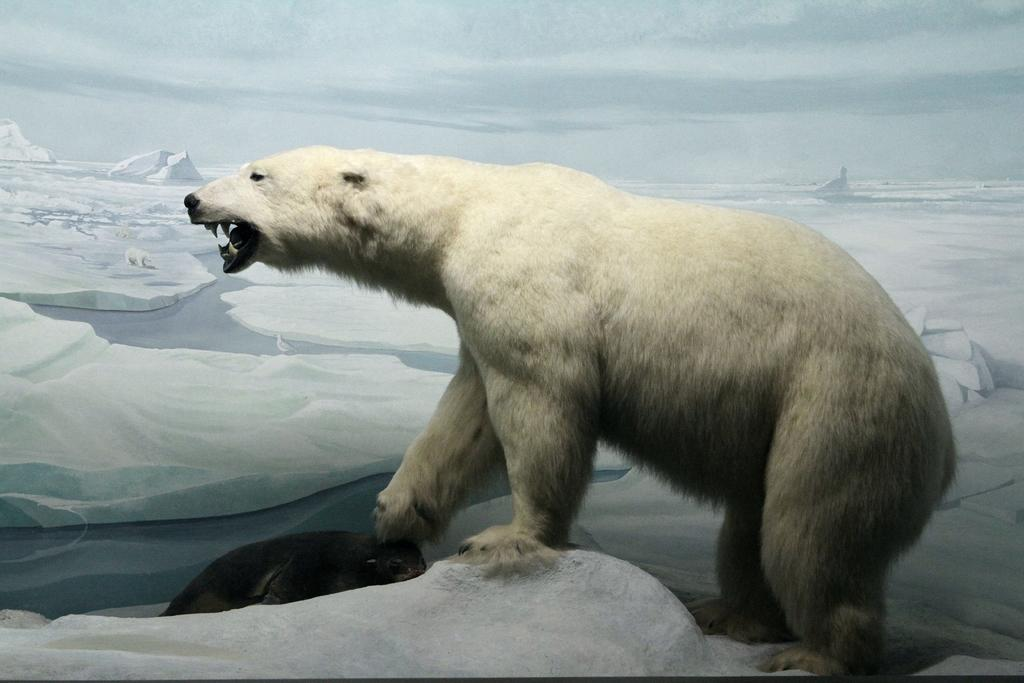What animals can be seen in the image? There is a polar bear and a seal in the image. Where are the animals located? Both the polar bear and the seal are on an iceberg. What can be seen in the background of the image? There are icebergs and water visible in the background, as well as the sky. Who is the owner of the tiger in the image? There is no tiger present in the image, so there is no owner to consider. 